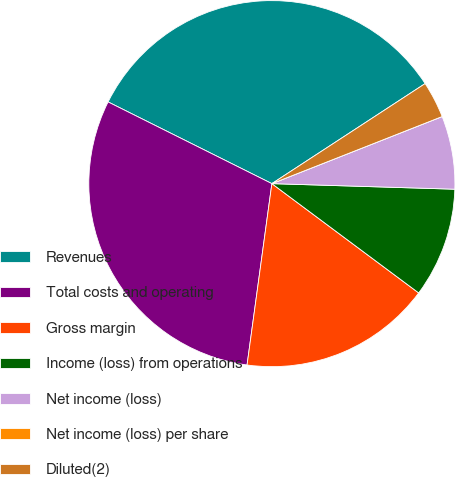<chart> <loc_0><loc_0><loc_500><loc_500><pie_chart><fcel>Revenues<fcel>Total costs and operating<fcel>Gross margin<fcel>Income (loss) from operations<fcel>Net income (loss)<fcel>Net income (loss) per share<fcel>Diluted(2)<nl><fcel>33.43%<fcel>30.2%<fcel>16.98%<fcel>9.7%<fcel>6.46%<fcel>0.0%<fcel>3.23%<nl></chart> 